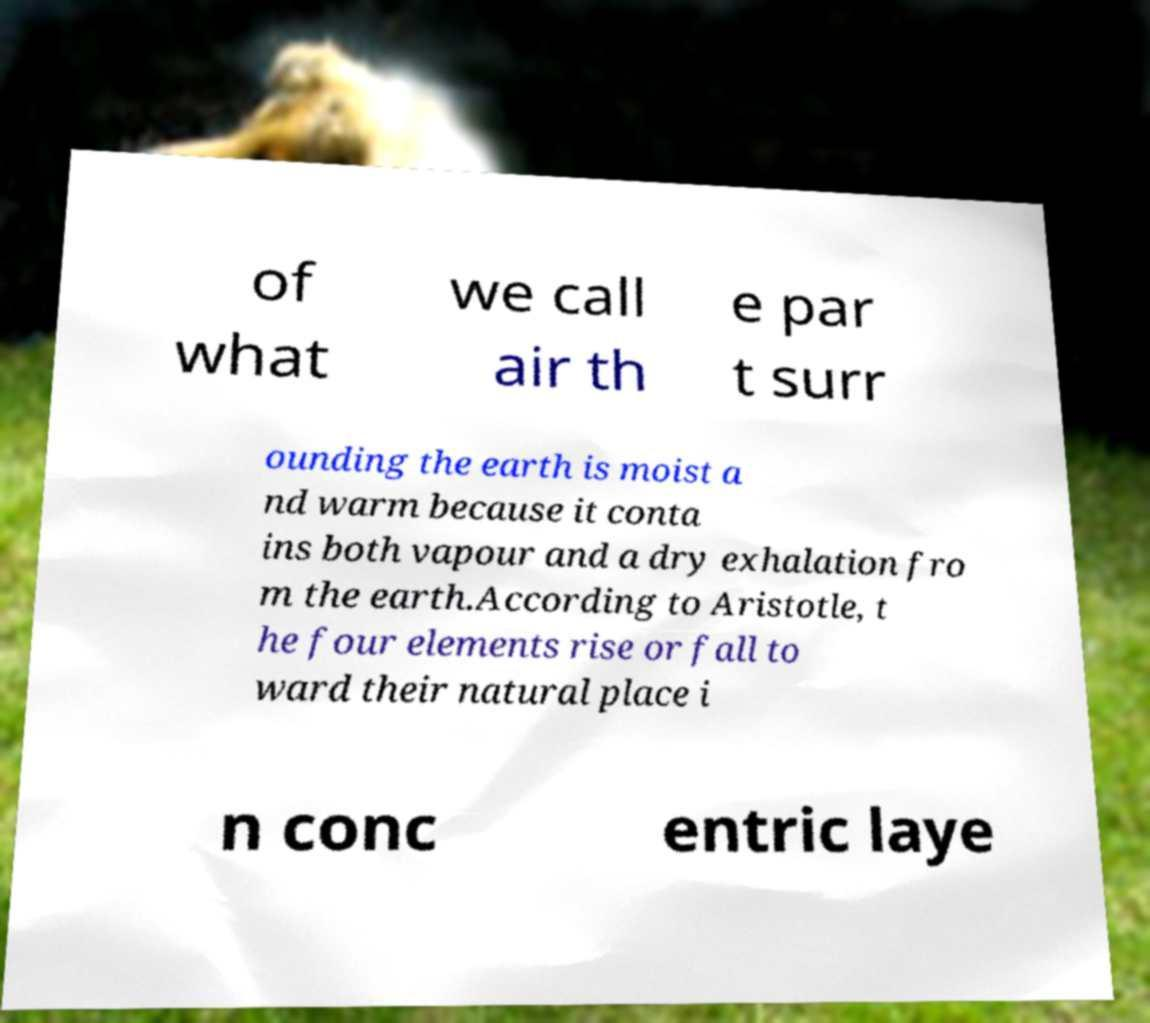Can you accurately transcribe the text from the provided image for me? of what we call air th e par t surr ounding the earth is moist a nd warm because it conta ins both vapour and a dry exhalation fro m the earth.According to Aristotle, t he four elements rise or fall to ward their natural place i n conc entric laye 